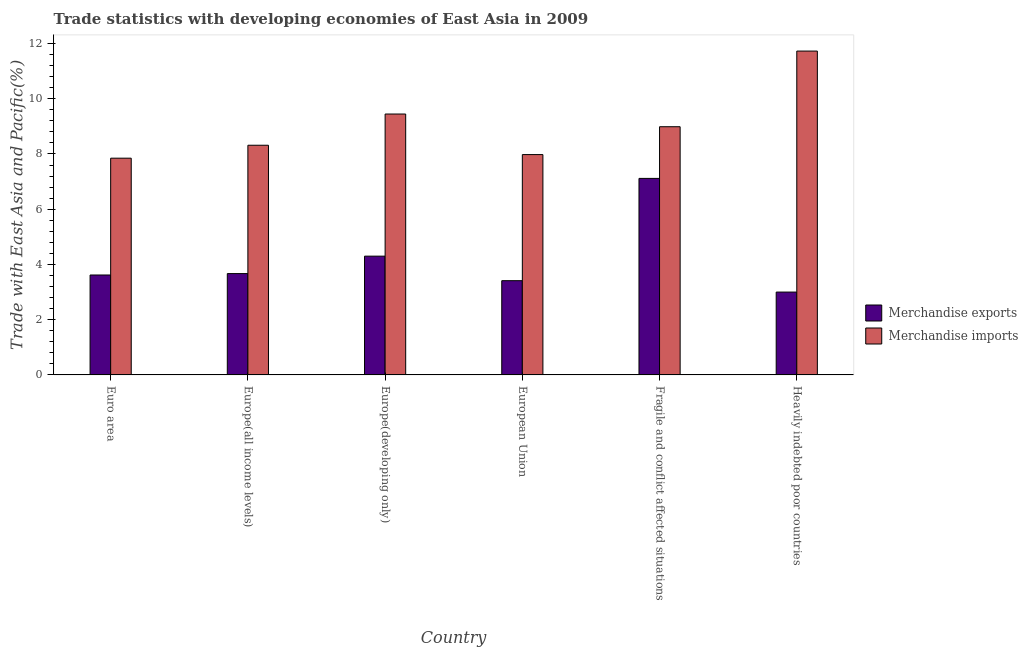Are the number of bars per tick equal to the number of legend labels?
Ensure brevity in your answer.  Yes. What is the label of the 5th group of bars from the left?
Keep it short and to the point. Fragile and conflict affected situations. What is the merchandise exports in European Union?
Keep it short and to the point. 3.41. Across all countries, what is the maximum merchandise imports?
Keep it short and to the point. 11.73. Across all countries, what is the minimum merchandise exports?
Offer a very short reply. 3. In which country was the merchandise imports maximum?
Offer a terse response. Heavily indebted poor countries. What is the total merchandise exports in the graph?
Provide a short and direct response. 25.11. What is the difference between the merchandise exports in Europe(developing only) and that in Fragile and conflict affected situations?
Make the answer very short. -2.82. What is the difference between the merchandise imports in European Union and the merchandise exports in Heavily indebted poor countries?
Provide a short and direct response. 4.98. What is the average merchandise imports per country?
Ensure brevity in your answer.  9.05. What is the difference between the merchandise imports and merchandise exports in European Union?
Your response must be concise. 4.57. In how many countries, is the merchandise imports greater than 4 %?
Your answer should be very brief. 6. What is the ratio of the merchandise exports in Euro area to that in European Union?
Give a very brief answer. 1.06. Is the difference between the merchandise exports in Europe(all income levels) and Europe(developing only) greater than the difference between the merchandise imports in Europe(all income levels) and Europe(developing only)?
Your response must be concise. Yes. What is the difference between the highest and the second highest merchandise imports?
Your answer should be very brief. 2.28. What is the difference between the highest and the lowest merchandise exports?
Give a very brief answer. 4.12. In how many countries, is the merchandise imports greater than the average merchandise imports taken over all countries?
Your answer should be very brief. 2. What does the 2nd bar from the left in European Union represents?
Make the answer very short. Merchandise imports. What does the 1st bar from the right in Euro area represents?
Make the answer very short. Merchandise imports. How many bars are there?
Offer a terse response. 12. Are all the bars in the graph horizontal?
Ensure brevity in your answer.  No. How many countries are there in the graph?
Offer a terse response. 6. Are the values on the major ticks of Y-axis written in scientific E-notation?
Make the answer very short. No. How many legend labels are there?
Offer a terse response. 2. What is the title of the graph?
Provide a succinct answer. Trade statistics with developing economies of East Asia in 2009. What is the label or title of the Y-axis?
Offer a terse response. Trade with East Asia and Pacific(%). What is the Trade with East Asia and Pacific(%) in Merchandise exports in Euro area?
Offer a very short reply. 3.62. What is the Trade with East Asia and Pacific(%) in Merchandise imports in Euro area?
Your answer should be compact. 7.85. What is the Trade with East Asia and Pacific(%) of Merchandise exports in Europe(all income levels)?
Your answer should be compact. 3.67. What is the Trade with East Asia and Pacific(%) of Merchandise imports in Europe(all income levels)?
Make the answer very short. 8.32. What is the Trade with East Asia and Pacific(%) in Merchandise exports in Europe(developing only)?
Offer a terse response. 4.3. What is the Trade with East Asia and Pacific(%) in Merchandise imports in Europe(developing only)?
Provide a succinct answer. 9.45. What is the Trade with East Asia and Pacific(%) in Merchandise exports in European Union?
Provide a succinct answer. 3.41. What is the Trade with East Asia and Pacific(%) in Merchandise imports in European Union?
Your answer should be compact. 7.98. What is the Trade with East Asia and Pacific(%) in Merchandise exports in Fragile and conflict affected situations?
Give a very brief answer. 7.12. What is the Trade with East Asia and Pacific(%) of Merchandise imports in Fragile and conflict affected situations?
Your answer should be very brief. 8.99. What is the Trade with East Asia and Pacific(%) of Merchandise exports in Heavily indebted poor countries?
Ensure brevity in your answer.  3. What is the Trade with East Asia and Pacific(%) in Merchandise imports in Heavily indebted poor countries?
Your response must be concise. 11.73. Across all countries, what is the maximum Trade with East Asia and Pacific(%) in Merchandise exports?
Your response must be concise. 7.12. Across all countries, what is the maximum Trade with East Asia and Pacific(%) of Merchandise imports?
Make the answer very short. 11.73. Across all countries, what is the minimum Trade with East Asia and Pacific(%) of Merchandise exports?
Your answer should be compact. 3. Across all countries, what is the minimum Trade with East Asia and Pacific(%) of Merchandise imports?
Offer a terse response. 7.85. What is the total Trade with East Asia and Pacific(%) in Merchandise exports in the graph?
Your response must be concise. 25.11. What is the total Trade with East Asia and Pacific(%) in Merchandise imports in the graph?
Provide a short and direct response. 54.3. What is the difference between the Trade with East Asia and Pacific(%) in Merchandise exports in Euro area and that in Europe(all income levels)?
Provide a short and direct response. -0.05. What is the difference between the Trade with East Asia and Pacific(%) of Merchandise imports in Euro area and that in Europe(all income levels)?
Provide a short and direct response. -0.47. What is the difference between the Trade with East Asia and Pacific(%) in Merchandise exports in Euro area and that in Europe(developing only)?
Give a very brief answer. -0.68. What is the difference between the Trade with East Asia and Pacific(%) in Merchandise imports in Euro area and that in Europe(developing only)?
Give a very brief answer. -1.6. What is the difference between the Trade with East Asia and Pacific(%) in Merchandise exports in Euro area and that in European Union?
Your response must be concise. 0.21. What is the difference between the Trade with East Asia and Pacific(%) of Merchandise imports in Euro area and that in European Union?
Ensure brevity in your answer.  -0.13. What is the difference between the Trade with East Asia and Pacific(%) of Merchandise exports in Euro area and that in Fragile and conflict affected situations?
Offer a very short reply. -3.5. What is the difference between the Trade with East Asia and Pacific(%) in Merchandise imports in Euro area and that in Fragile and conflict affected situations?
Ensure brevity in your answer.  -1.14. What is the difference between the Trade with East Asia and Pacific(%) in Merchandise exports in Euro area and that in Heavily indebted poor countries?
Offer a terse response. 0.62. What is the difference between the Trade with East Asia and Pacific(%) in Merchandise imports in Euro area and that in Heavily indebted poor countries?
Your response must be concise. -3.88. What is the difference between the Trade with East Asia and Pacific(%) of Merchandise exports in Europe(all income levels) and that in Europe(developing only)?
Make the answer very short. -0.63. What is the difference between the Trade with East Asia and Pacific(%) in Merchandise imports in Europe(all income levels) and that in Europe(developing only)?
Offer a terse response. -1.13. What is the difference between the Trade with East Asia and Pacific(%) in Merchandise exports in Europe(all income levels) and that in European Union?
Provide a short and direct response. 0.26. What is the difference between the Trade with East Asia and Pacific(%) of Merchandise imports in Europe(all income levels) and that in European Union?
Offer a very short reply. 0.34. What is the difference between the Trade with East Asia and Pacific(%) of Merchandise exports in Europe(all income levels) and that in Fragile and conflict affected situations?
Ensure brevity in your answer.  -3.45. What is the difference between the Trade with East Asia and Pacific(%) in Merchandise imports in Europe(all income levels) and that in Fragile and conflict affected situations?
Provide a short and direct response. -0.67. What is the difference between the Trade with East Asia and Pacific(%) in Merchandise exports in Europe(all income levels) and that in Heavily indebted poor countries?
Offer a very short reply. 0.67. What is the difference between the Trade with East Asia and Pacific(%) of Merchandise imports in Europe(all income levels) and that in Heavily indebted poor countries?
Offer a very short reply. -3.41. What is the difference between the Trade with East Asia and Pacific(%) of Merchandise exports in Europe(developing only) and that in European Union?
Give a very brief answer. 0.89. What is the difference between the Trade with East Asia and Pacific(%) in Merchandise imports in Europe(developing only) and that in European Union?
Make the answer very short. 1.47. What is the difference between the Trade with East Asia and Pacific(%) of Merchandise exports in Europe(developing only) and that in Fragile and conflict affected situations?
Give a very brief answer. -2.82. What is the difference between the Trade with East Asia and Pacific(%) in Merchandise imports in Europe(developing only) and that in Fragile and conflict affected situations?
Make the answer very short. 0.46. What is the difference between the Trade with East Asia and Pacific(%) in Merchandise exports in Europe(developing only) and that in Heavily indebted poor countries?
Keep it short and to the point. 1.3. What is the difference between the Trade with East Asia and Pacific(%) of Merchandise imports in Europe(developing only) and that in Heavily indebted poor countries?
Your answer should be compact. -2.28. What is the difference between the Trade with East Asia and Pacific(%) in Merchandise exports in European Union and that in Fragile and conflict affected situations?
Your answer should be compact. -3.7. What is the difference between the Trade with East Asia and Pacific(%) of Merchandise imports in European Union and that in Fragile and conflict affected situations?
Provide a succinct answer. -1.01. What is the difference between the Trade with East Asia and Pacific(%) in Merchandise exports in European Union and that in Heavily indebted poor countries?
Ensure brevity in your answer.  0.41. What is the difference between the Trade with East Asia and Pacific(%) of Merchandise imports in European Union and that in Heavily indebted poor countries?
Offer a very short reply. -3.75. What is the difference between the Trade with East Asia and Pacific(%) of Merchandise exports in Fragile and conflict affected situations and that in Heavily indebted poor countries?
Provide a succinct answer. 4.12. What is the difference between the Trade with East Asia and Pacific(%) in Merchandise imports in Fragile and conflict affected situations and that in Heavily indebted poor countries?
Give a very brief answer. -2.74. What is the difference between the Trade with East Asia and Pacific(%) in Merchandise exports in Euro area and the Trade with East Asia and Pacific(%) in Merchandise imports in Europe(all income levels)?
Make the answer very short. -4.7. What is the difference between the Trade with East Asia and Pacific(%) in Merchandise exports in Euro area and the Trade with East Asia and Pacific(%) in Merchandise imports in Europe(developing only)?
Your response must be concise. -5.83. What is the difference between the Trade with East Asia and Pacific(%) of Merchandise exports in Euro area and the Trade with East Asia and Pacific(%) of Merchandise imports in European Union?
Give a very brief answer. -4.36. What is the difference between the Trade with East Asia and Pacific(%) of Merchandise exports in Euro area and the Trade with East Asia and Pacific(%) of Merchandise imports in Fragile and conflict affected situations?
Offer a terse response. -5.37. What is the difference between the Trade with East Asia and Pacific(%) in Merchandise exports in Euro area and the Trade with East Asia and Pacific(%) in Merchandise imports in Heavily indebted poor countries?
Provide a short and direct response. -8.11. What is the difference between the Trade with East Asia and Pacific(%) in Merchandise exports in Europe(all income levels) and the Trade with East Asia and Pacific(%) in Merchandise imports in Europe(developing only)?
Ensure brevity in your answer.  -5.78. What is the difference between the Trade with East Asia and Pacific(%) in Merchandise exports in Europe(all income levels) and the Trade with East Asia and Pacific(%) in Merchandise imports in European Union?
Provide a short and direct response. -4.31. What is the difference between the Trade with East Asia and Pacific(%) in Merchandise exports in Europe(all income levels) and the Trade with East Asia and Pacific(%) in Merchandise imports in Fragile and conflict affected situations?
Your response must be concise. -5.32. What is the difference between the Trade with East Asia and Pacific(%) in Merchandise exports in Europe(all income levels) and the Trade with East Asia and Pacific(%) in Merchandise imports in Heavily indebted poor countries?
Make the answer very short. -8.06. What is the difference between the Trade with East Asia and Pacific(%) in Merchandise exports in Europe(developing only) and the Trade with East Asia and Pacific(%) in Merchandise imports in European Union?
Offer a terse response. -3.68. What is the difference between the Trade with East Asia and Pacific(%) in Merchandise exports in Europe(developing only) and the Trade with East Asia and Pacific(%) in Merchandise imports in Fragile and conflict affected situations?
Give a very brief answer. -4.69. What is the difference between the Trade with East Asia and Pacific(%) of Merchandise exports in Europe(developing only) and the Trade with East Asia and Pacific(%) of Merchandise imports in Heavily indebted poor countries?
Keep it short and to the point. -7.43. What is the difference between the Trade with East Asia and Pacific(%) of Merchandise exports in European Union and the Trade with East Asia and Pacific(%) of Merchandise imports in Fragile and conflict affected situations?
Your response must be concise. -5.57. What is the difference between the Trade with East Asia and Pacific(%) in Merchandise exports in European Union and the Trade with East Asia and Pacific(%) in Merchandise imports in Heavily indebted poor countries?
Offer a very short reply. -8.31. What is the difference between the Trade with East Asia and Pacific(%) of Merchandise exports in Fragile and conflict affected situations and the Trade with East Asia and Pacific(%) of Merchandise imports in Heavily indebted poor countries?
Provide a short and direct response. -4.61. What is the average Trade with East Asia and Pacific(%) of Merchandise exports per country?
Ensure brevity in your answer.  4.19. What is the average Trade with East Asia and Pacific(%) of Merchandise imports per country?
Give a very brief answer. 9.05. What is the difference between the Trade with East Asia and Pacific(%) in Merchandise exports and Trade with East Asia and Pacific(%) in Merchandise imports in Euro area?
Ensure brevity in your answer.  -4.23. What is the difference between the Trade with East Asia and Pacific(%) in Merchandise exports and Trade with East Asia and Pacific(%) in Merchandise imports in Europe(all income levels)?
Offer a very short reply. -4.65. What is the difference between the Trade with East Asia and Pacific(%) in Merchandise exports and Trade with East Asia and Pacific(%) in Merchandise imports in Europe(developing only)?
Give a very brief answer. -5.15. What is the difference between the Trade with East Asia and Pacific(%) in Merchandise exports and Trade with East Asia and Pacific(%) in Merchandise imports in European Union?
Offer a very short reply. -4.57. What is the difference between the Trade with East Asia and Pacific(%) in Merchandise exports and Trade with East Asia and Pacific(%) in Merchandise imports in Fragile and conflict affected situations?
Offer a terse response. -1.87. What is the difference between the Trade with East Asia and Pacific(%) of Merchandise exports and Trade with East Asia and Pacific(%) of Merchandise imports in Heavily indebted poor countries?
Ensure brevity in your answer.  -8.73. What is the ratio of the Trade with East Asia and Pacific(%) of Merchandise exports in Euro area to that in Europe(all income levels)?
Give a very brief answer. 0.99. What is the ratio of the Trade with East Asia and Pacific(%) of Merchandise imports in Euro area to that in Europe(all income levels)?
Provide a succinct answer. 0.94. What is the ratio of the Trade with East Asia and Pacific(%) of Merchandise exports in Euro area to that in Europe(developing only)?
Provide a short and direct response. 0.84. What is the ratio of the Trade with East Asia and Pacific(%) of Merchandise imports in Euro area to that in Europe(developing only)?
Provide a succinct answer. 0.83. What is the ratio of the Trade with East Asia and Pacific(%) in Merchandise exports in Euro area to that in European Union?
Your response must be concise. 1.06. What is the ratio of the Trade with East Asia and Pacific(%) in Merchandise imports in Euro area to that in European Union?
Provide a short and direct response. 0.98. What is the ratio of the Trade with East Asia and Pacific(%) in Merchandise exports in Euro area to that in Fragile and conflict affected situations?
Offer a very short reply. 0.51. What is the ratio of the Trade with East Asia and Pacific(%) of Merchandise imports in Euro area to that in Fragile and conflict affected situations?
Give a very brief answer. 0.87. What is the ratio of the Trade with East Asia and Pacific(%) of Merchandise exports in Euro area to that in Heavily indebted poor countries?
Your answer should be compact. 1.21. What is the ratio of the Trade with East Asia and Pacific(%) of Merchandise imports in Euro area to that in Heavily indebted poor countries?
Give a very brief answer. 0.67. What is the ratio of the Trade with East Asia and Pacific(%) of Merchandise exports in Europe(all income levels) to that in Europe(developing only)?
Provide a succinct answer. 0.85. What is the ratio of the Trade with East Asia and Pacific(%) in Merchandise imports in Europe(all income levels) to that in Europe(developing only)?
Your answer should be very brief. 0.88. What is the ratio of the Trade with East Asia and Pacific(%) in Merchandise exports in Europe(all income levels) to that in European Union?
Offer a very short reply. 1.08. What is the ratio of the Trade with East Asia and Pacific(%) of Merchandise imports in Europe(all income levels) to that in European Union?
Keep it short and to the point. 1.04. What is the ratio of the Trade with East Asia and Pacific(%) of Merchandise exports in Europe(all income levels) to that in Fragile and conflict affected situations?
Keep it short and to the point. 0.52. What is the ratio of the Trade with East Asia and Pacific(%) of Merchandise imports in Europe(all income levels) to that in Fragile and conflict affected situations?
Your response must be concise. 0.93. What is the ratio of the Trade with East Asia and Pacific(%) in Merchandise exports in Europe(all income levels) to that in Heavily indebted poor countries?
Provide a succinct answer. 1.22. What is the ratio of the Trade with East Asia and Pacific(%) in Merchandise imports in Europe(all income levels) to that in Heavily indebted poor countries?
Give a very brief answer. 0.71. What is the ratio of the Trade with East Asia and Pacific(%) in Merchandise exports in Europe(developing only) to that in European Union?
Provide a succinct answer. 1.26. What is the ratio of the Trade with East Asia and Pacific(%) of Merchandise imports in Europe(developing only) to that in European Union?
Give a very brief answer. 1.18. What is the ratio of the Trade with East Asia and Pacific(%) of Merchandise exports in Europe(developing only) to that in Fragile and conflict affected situations?
Keep it short and to the point. 0.6. What is the ratio of the Trade with East Asia and Pacific(%) in Merchandise imports in Europe(developing only) to that in Fragile and conflict affected situations?
Offer a very short reply. 1.05. What is the ratio of the Trade with East Asia and Pacific(%) in Merchandise exports in Europe(developing only) to that in Heavily indebted poor countries?
Your response must be concise. 1.43. What is the ratio of the Trade with East Asia and Pacific(%) of Merchandise imports in Europe(developing only) to that in Heavily indebted poor countries?
Make the answer very short. 0.81. What is the ratio of the Trade with East Asia and Pacific(%) in Merchandise exports in European Union to that in Fragile and conflict affected situations?
Offer a very short reply. 0.48. What is the ratio of the Trade with East Asia and Pacific(%) of Merchandise imports in European Union to that in Fragile and conflict affected situations?
Ensure brevity in your answer.  0.89. What is the ratio of the Trade with East Asia and Pacific(%) in Merchandise exports in European Union to that in Heavily indebted poor countries?
Keep it short and to the point. 1.14. What is the ratio of the Trade with East Asia and Pacific(%) in Merchandise imports in European Union to that in Heavily indebted poor countries?
Offer a very short reply. 0.68. What is the ratio of the Trade with East Asia and Pacific(%) in Merchandise exports in Fragile and conflict affected situations to that in Heavily indebted poor countries?
Offer a very short reply. 2.37. What is the ratio of the Trade with East Asia and Pacific(%) in Merchandise imports in Fragile and conflict affected situations to that in Heavily indebted poor countries?
Make the answer very short. 0.77. What is the difference between the highest and the second highest Trade with East Asia and Pacific(%) of Merchandise exports?
Your answer should be compact. 2.82. What is the difference between the highest and the second highest Trade with East Asia and Pacific(%) in Merchandise imports?
Make the answer very short. 2.28. What is the difference between the highest and the lowest Trade with East Asia and Pacific(%) of Merchandise exports?
Give a very brief answer. 4.12. What is the difference between the highest and the lowest Trade with East Asia and Pacific(%) of Merchandise imports?
Give a very brief answer. 3.88. 